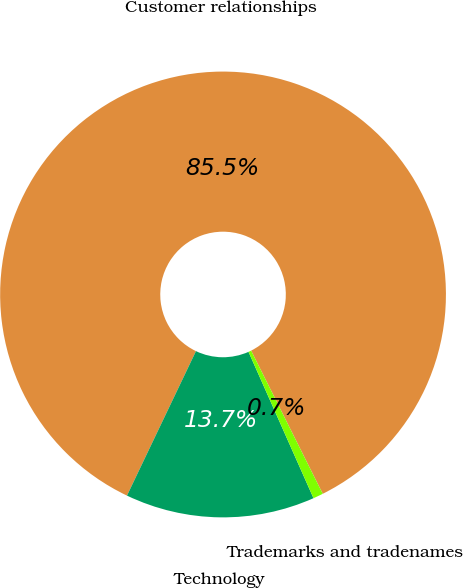<chart> <loc_0><loc_0><loc_500><loc_500><pie_chart><fcel>Customer relationships<fcel>Technology<fcel>Trademarks and tradenames<nl><fcel>85.52%<fcel>13.74%<fcel>0.73%<nl></chart> 